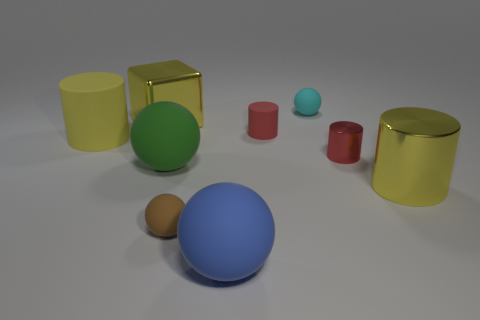How many objects are either red cylinders or big purple cylinders?
Make the answer very short. 2. How many other things are the same shape as the brown object?
Ensure brevity in your answer.  3. Is the big ball on the right side of the tiny brown ball made of the same material as the big yellow cylinder in front of the small red metal cylinder?
Make the answer very short. No. What shape is the object that is both left of the big green sphere and behind the yellow matte thing?
Give a very brief answer. Cube. Is there anything else that is made of the same material as the cyan thing?
Provide a succinct answer. Yes. What material is the object that is in front of the big yellow matte thing and behind the green matte object?
Your answer should be very brief. Metal. What shape is the large yellow object that is made of the same material as the large blue thing?
Offer a very short reply. Cylinder. Is there any other thing that is the same color as the shiny cube?
Offer a very short reply. Yes. Are there more green matte spheres that are behind the green thing than yellow rubber cylinders?
Offer a terse response. No. What is the cyan ball made of?
Provide a succinct answer. Rubber. 